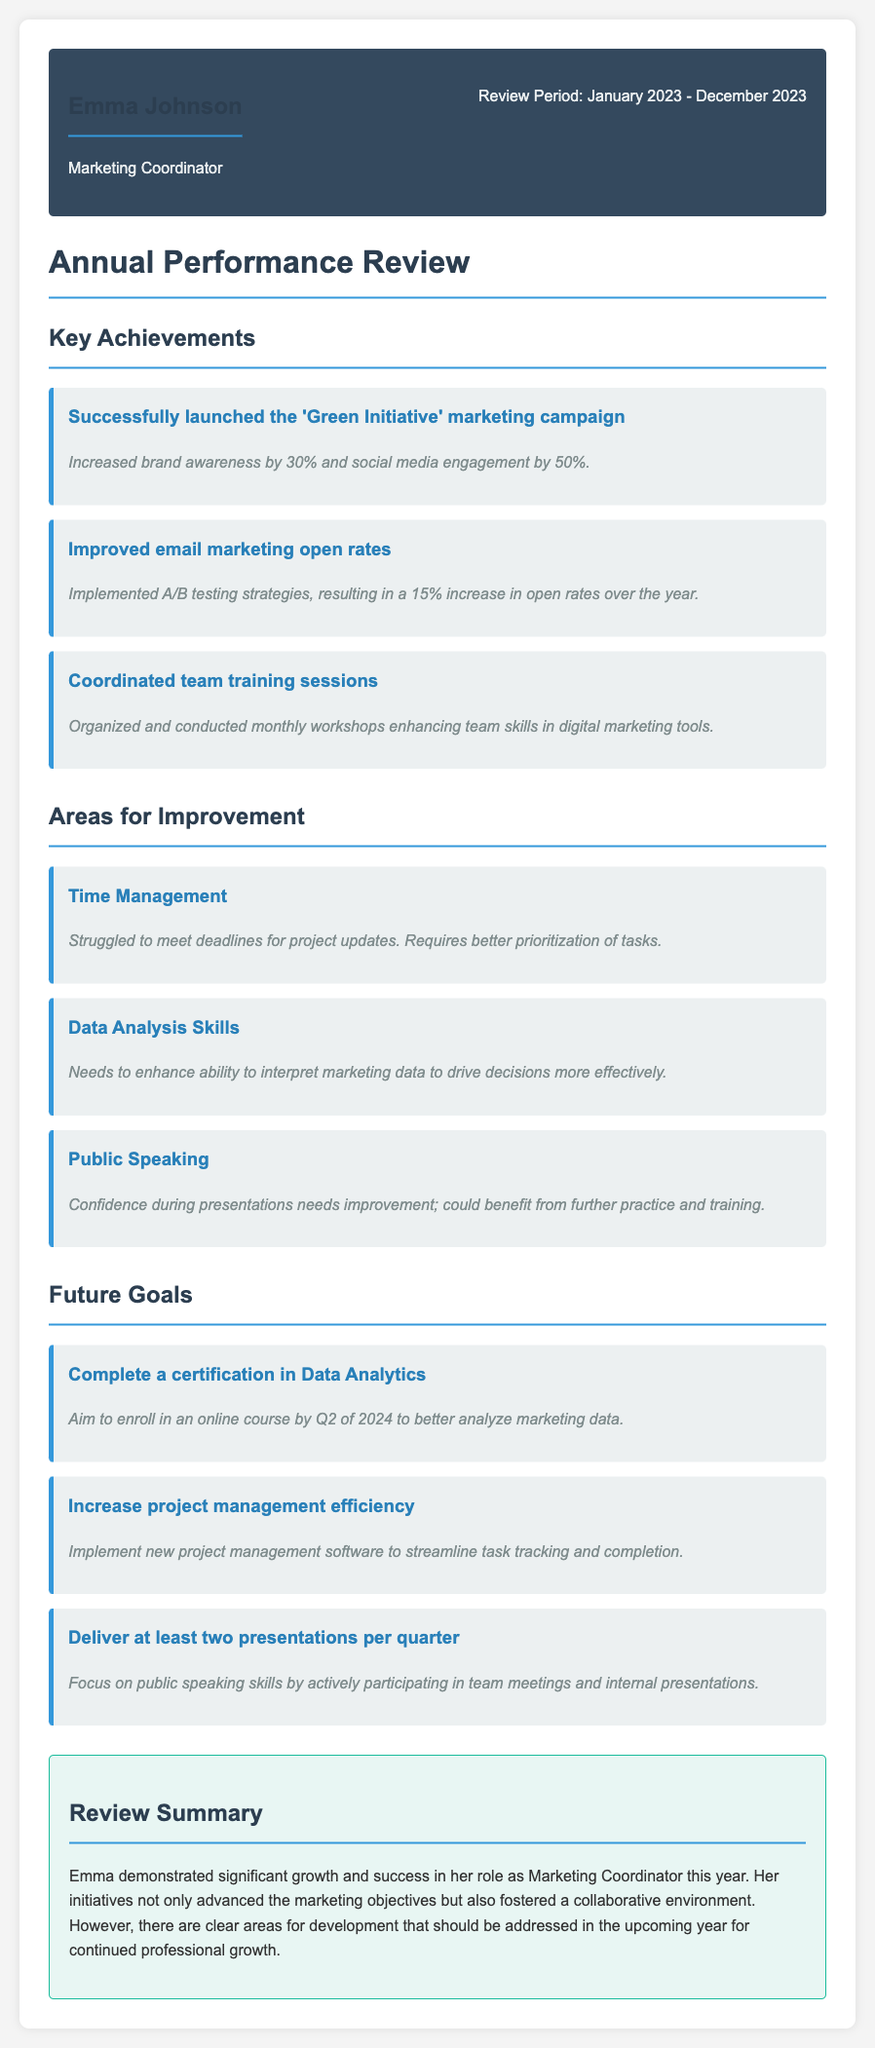What is the name of the employee? The employee's name is highlighted at the beginning of the document as part of the employee info section.
Answer: Emma Johnson What is the employee's position? The position is listed in the employee info section.
Answer: Marketing Coordinator What was the review period? The review period is specified in the employee info section.
Answer: January 2023 - December 2023 How much did the 'Green Initiative' marketing campaign increase brand awareness? This information is found in the key achievements section related to the marketing campaign.
Answer: 30% What is one area for improvement related to time management? This comes from the areas for improvement section detailing specific struggles.
Answer: Struggled to meet deadlines What certification does the employee aim to complete? This is included in the future goals section regarding the employee's aspirations.
Answer: Data Analytics How many presentations does the employee plan to deliver per quarter? This number is specified in the future goals section regarding public speaking.
Answer: Two presentations What major tool does the employee want to implement for project management? This is mentioned in the future goals section relating to improving efficiency.
Answer: New project management software What was the overall impression of Emma's performance? The summary provides insights into the general evaluation of her work throughout the year.
Answer: Significant growth and success 